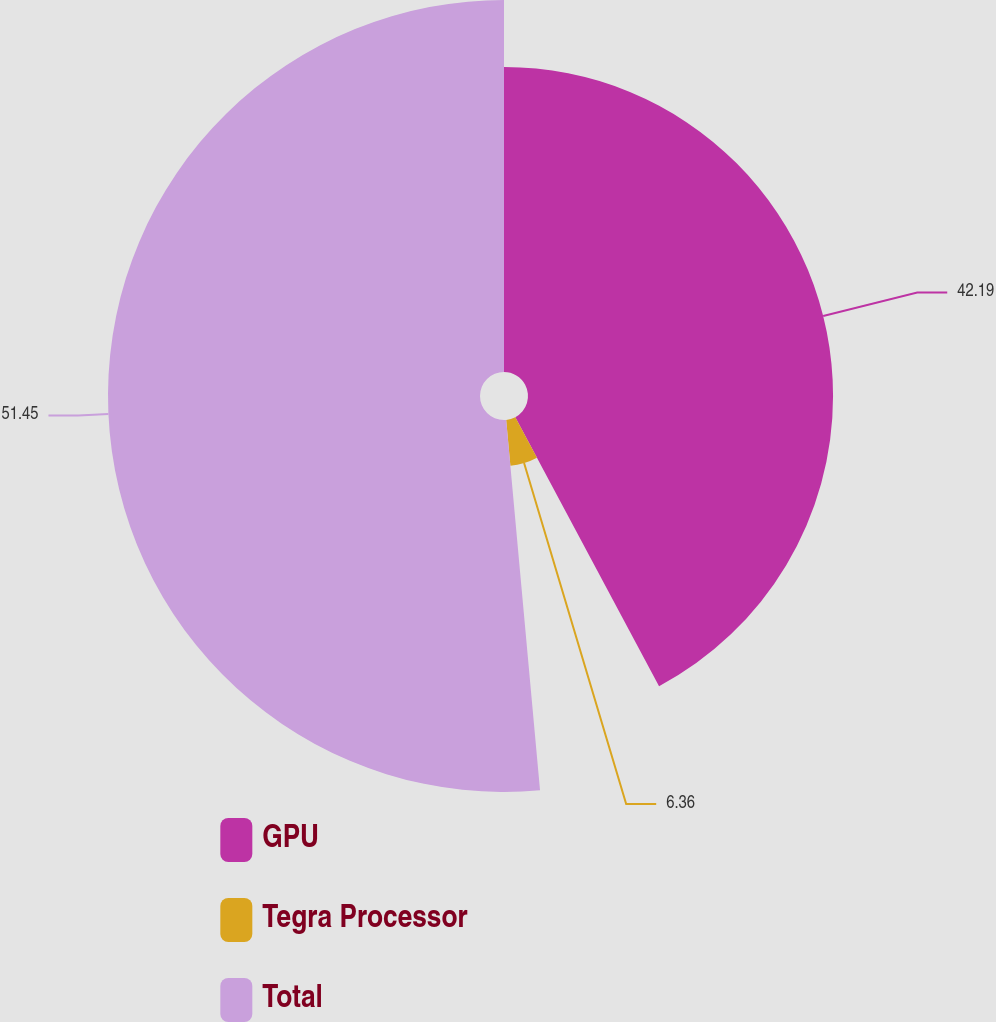Convert chart to OTSL. <chart><loc_0><loc_0><loc_500><loc_500><pie_chart><fcel>GPU<fcel>Tegra Processor<fcel>Total<nl><fcel>42.19%<fcel>6.36%<fcel>51.45%<nl></chart> 